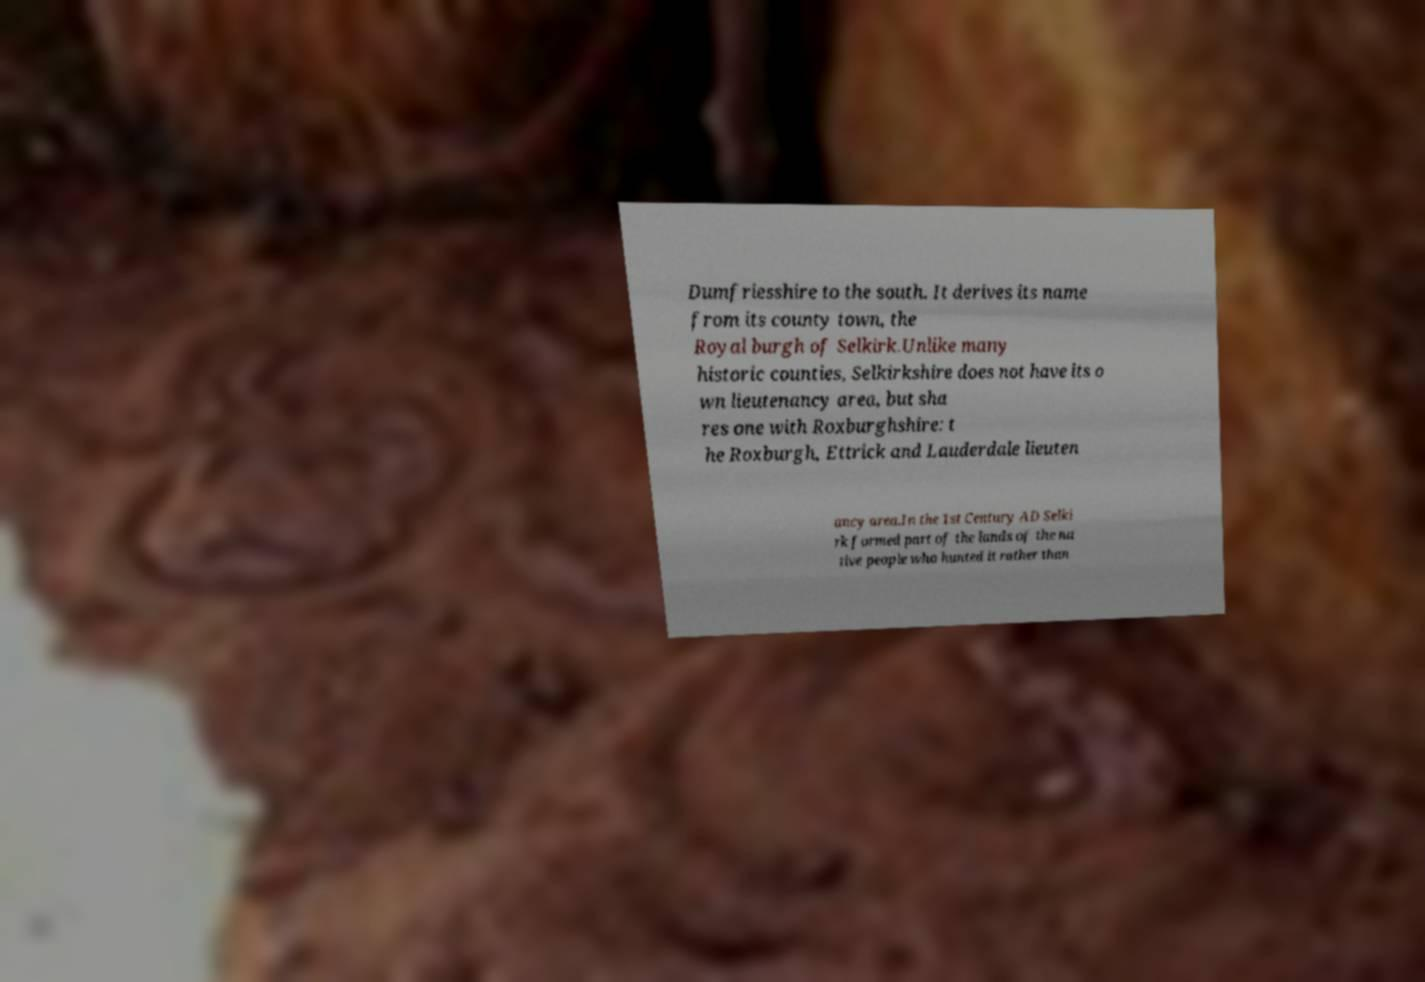What messages or text are displayed in this image? I need them in a readable, typed format. Dumfriesshire to the south. It derives its name from its county town, the Royal burgh of Selkirk.Unlike many historic counties, Selkirkshire does not have its o wn lieutenancy area, but sha res one with Roxburghshire: t he Roxburgh, Ettrick and Lauderdale lieuten ancy area.In the 1st Century AD Selki rk formed part of the lands of the na tive people who hunted it rather than 